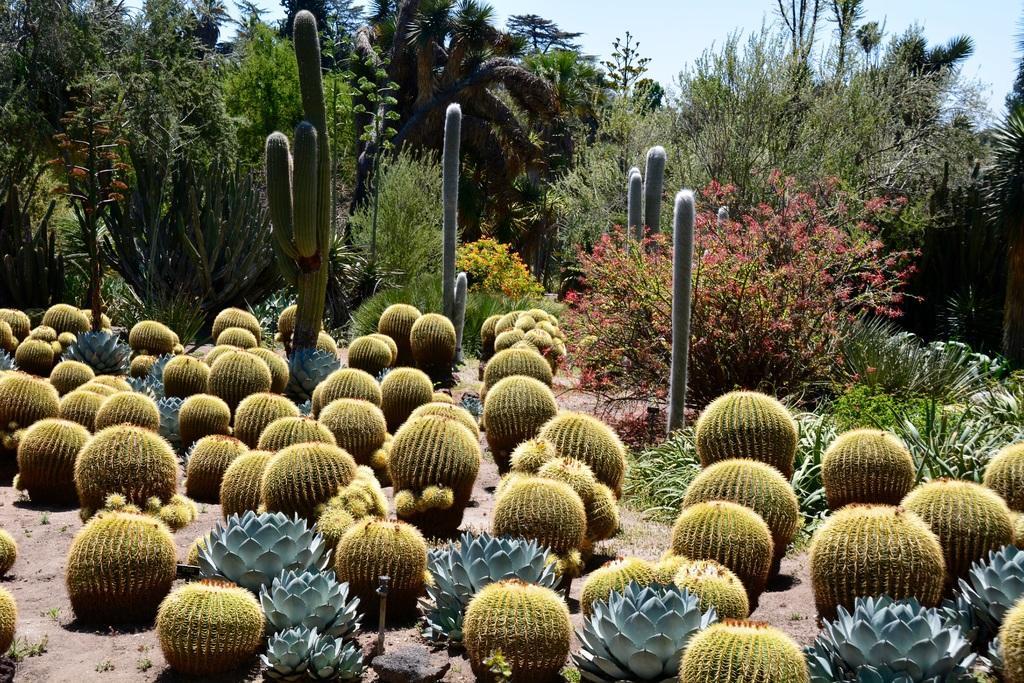Can you describe this image briefly? In this picture we can see desert plants on the ground and in the background we can see trees, sky. 